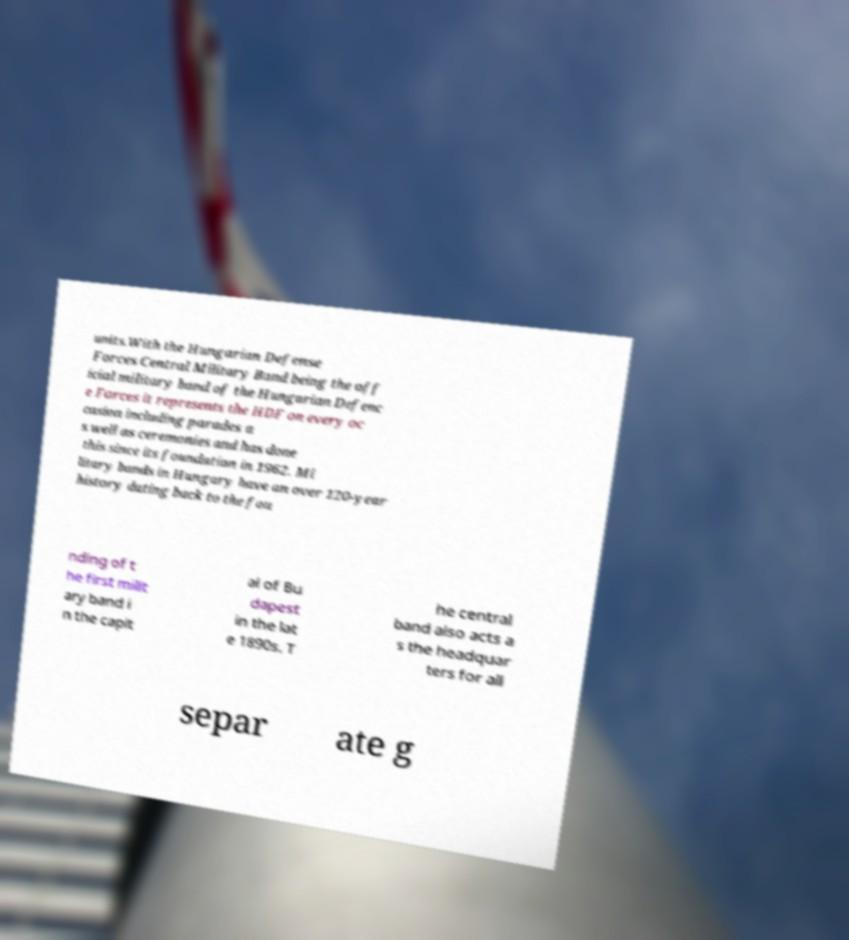For documentation purposes, I need the text within this image transcribed. Could you provide that? units.With the Hungarian Defense Forces Central Military Band being the off icial military band of the Hungarian Defenc e Forces it represents the HDF on every oc casion including parades a s well as ceremonies and has done this since its foundation in 1962. Mi litary bands in Hungary have an over 120-year history dating back to the fou nding of t he first milit ary band i n the capit al of Bu dapest in the lat e 1890s. T he central band also acts a s the headquar ters for all separ ate g 